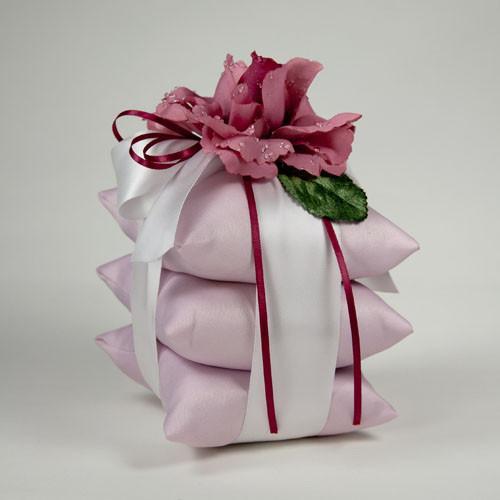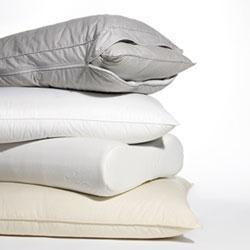The first image is the image on the left, the second image is the image on the right. Considering the images on both sides, is "One of the stacks has exactly three pillows and is decorated with ribbons and flowers." valid? Answer yes or no. Yes. 